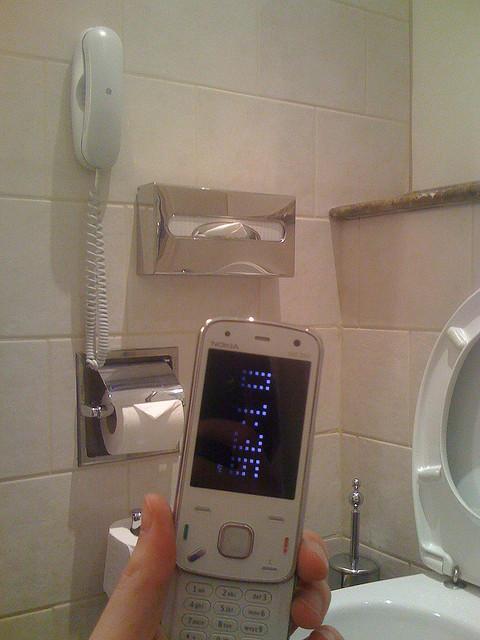What is the setting if there is a phone in the bathroom?
Answer briefly. Hotel. Is the person going to put the phone in the toilet?
Quick response, please. No. Are there people in the room?
Short answer required. Yes. How many phones are in the picture?
Quick response, please. 1. 